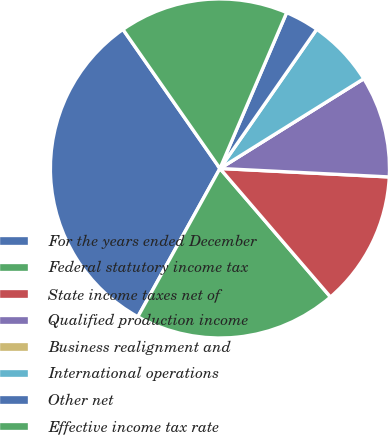<chart> <loc_0><loc_0><loc_500><loc_500><pie_chart><fcel>For the years ended December<fcel>Federal statutory income tax<fcel>State income taxes net of<fcel>Qualified production income<fcel>Business realignment and<fcel>International operations<fcel>Other net<fcel>Effective income tax rate<nl><fcel>32.26%<fcel>19.35%<fcel>12.9%<fcel>9.68%<fcel>0.0%<fcel>6.45%<fcel>3.23%<fcel>16.13%<nl></chart> 